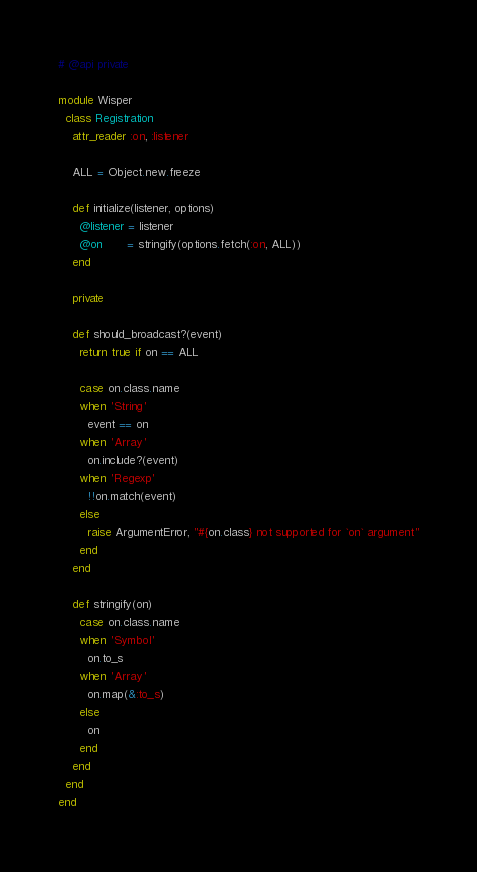Convert code to text. <code><loc_0><loc_0><loc_500><loc_500><_Ruby_># @api private

module Wisper
  class Registration
    attr_reader :on, :listener

    ALL = Object.new.freeze

    def initialize(listener, options)
      @listener = listener
      @on       = stringify(options.fetch(:on, ALL))
    end

    private

    def should_broadcast?(event)
      return true if on == ALL

      case on.class.name
      when 'String'
        event == on
      when 'Array'
        on.include?(event)
      when 'Regexp'
        !!on.match(event)
      else
        raise ArgumentError, "#{on.class} not supported for `on` argument"
      end
    end

    def stringify(on)
      case on.class.name
      when 'Symbol'
        on.to_s
      when 'Array'
        on.map(&:to_s)
      else
        on
      end
    end
  end
end
</code> 